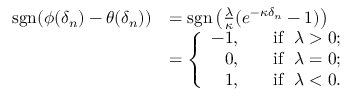<formula> <loc_0><loc_0><loc_500><loc_500>\begin{array} { r l } { s g n ( \phi ( \delta _ { n } ) - \theta ( \delta _ { n } ) ) } & { = s g n \left ( \frac { \lambda } { \kappa } ( e ^ { - \kappa \delta _ { n } } - 1 ) \right ) } \\ & { = \left \{ \begin{array} { r l } { - 1 , } & { i f \lambda > 0 ; } \\ { 0 , } & { i f \lambda = 0 ; } \\ { 1 , } & { i f \lambda < 0 . } \end{array} } \end{array}</formula> 